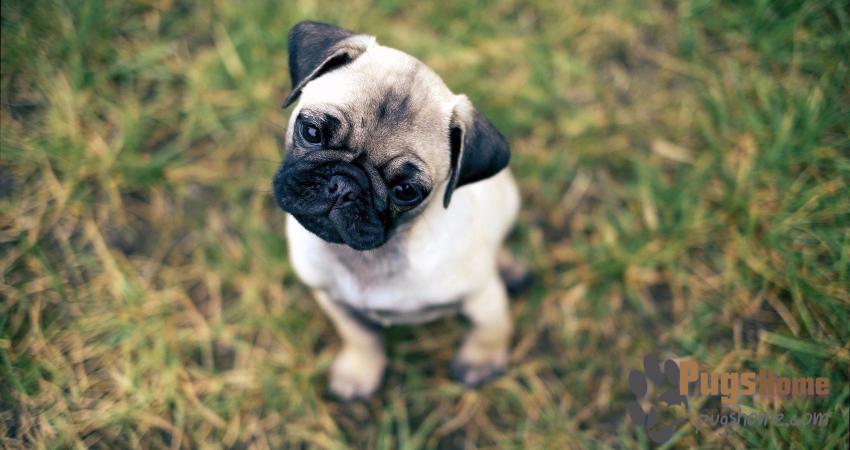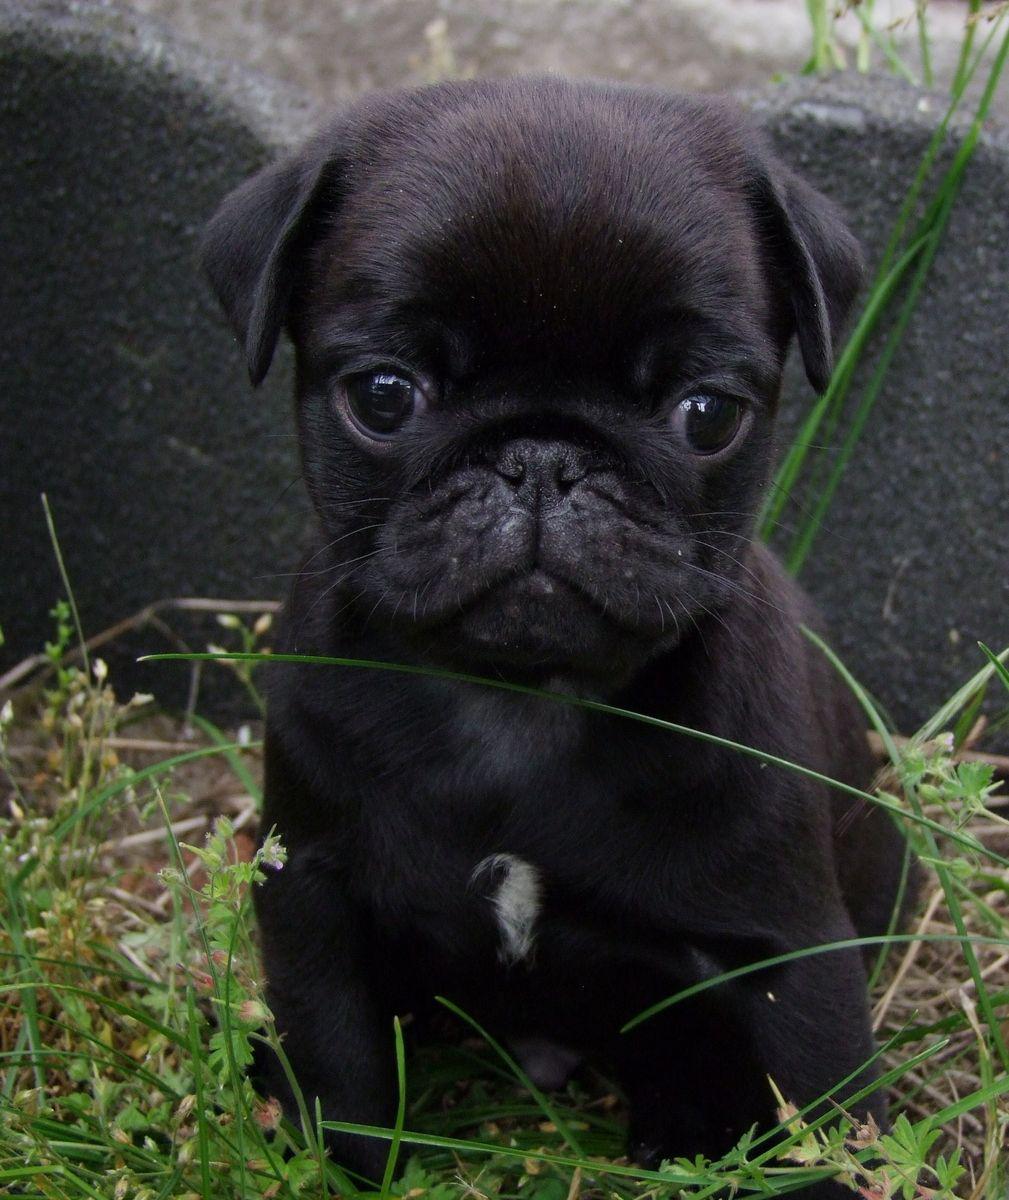The first image is the image on the left, the second image is the image on the right. Considering the images on both sides, is "The left image contains at least one pug dog outside on grass chewing on an item." valid? Answer yes or no. No. The first image is the image on the left, the second image is the image on the right. Considering the images on both sides, is "The left image includes at least one black pug with something black-and-white grasped in its mouth." valid? Answer yes or no. No. 